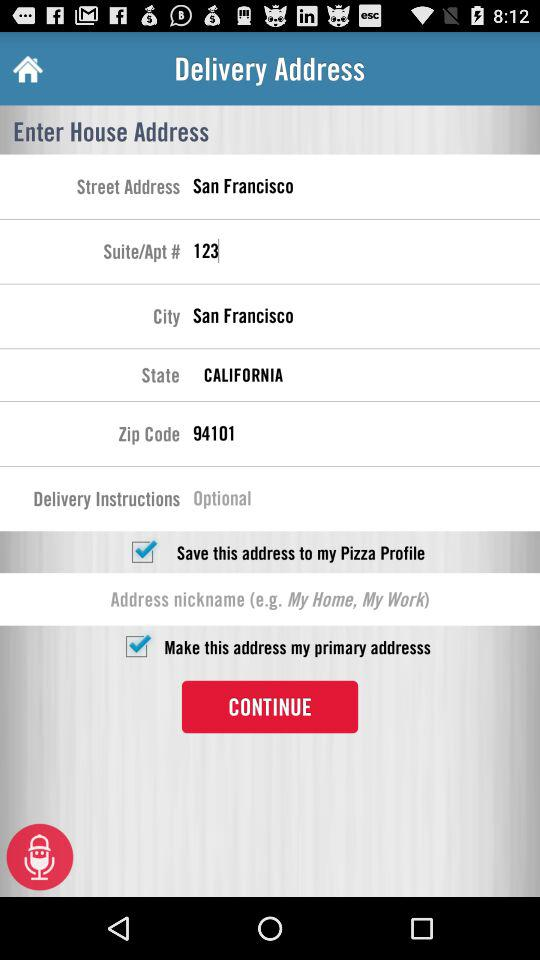What is the street address? The street address is San Francisco. 